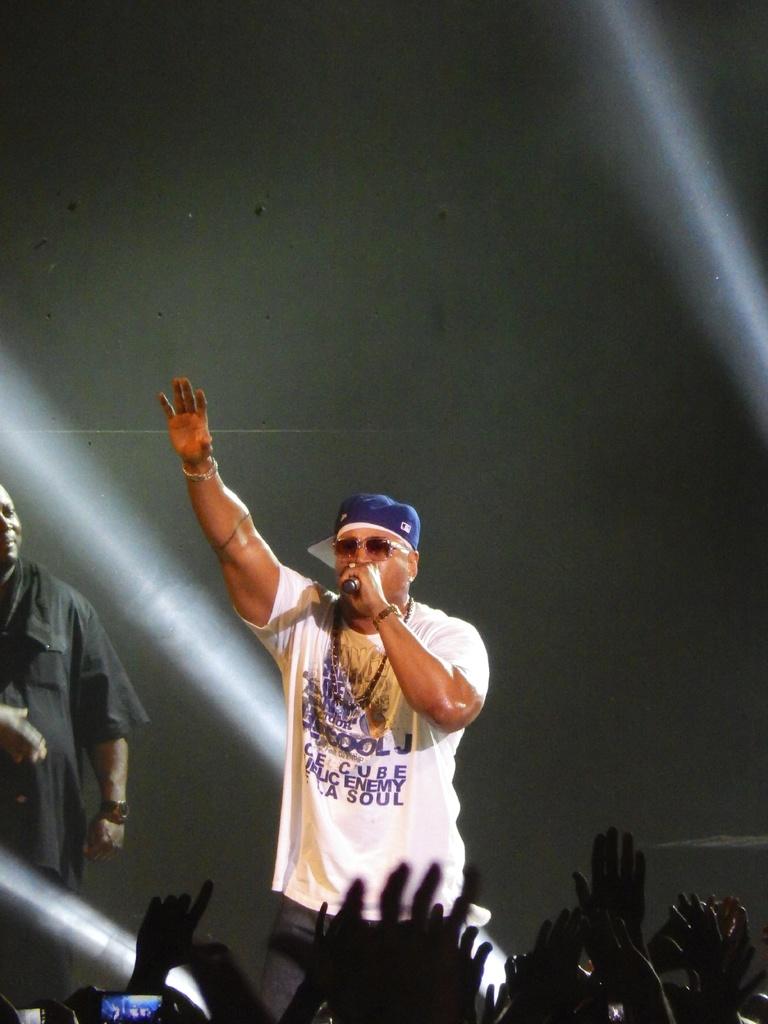What musicians are listed on his shirt?
Make the answer very short. Ice cube. 